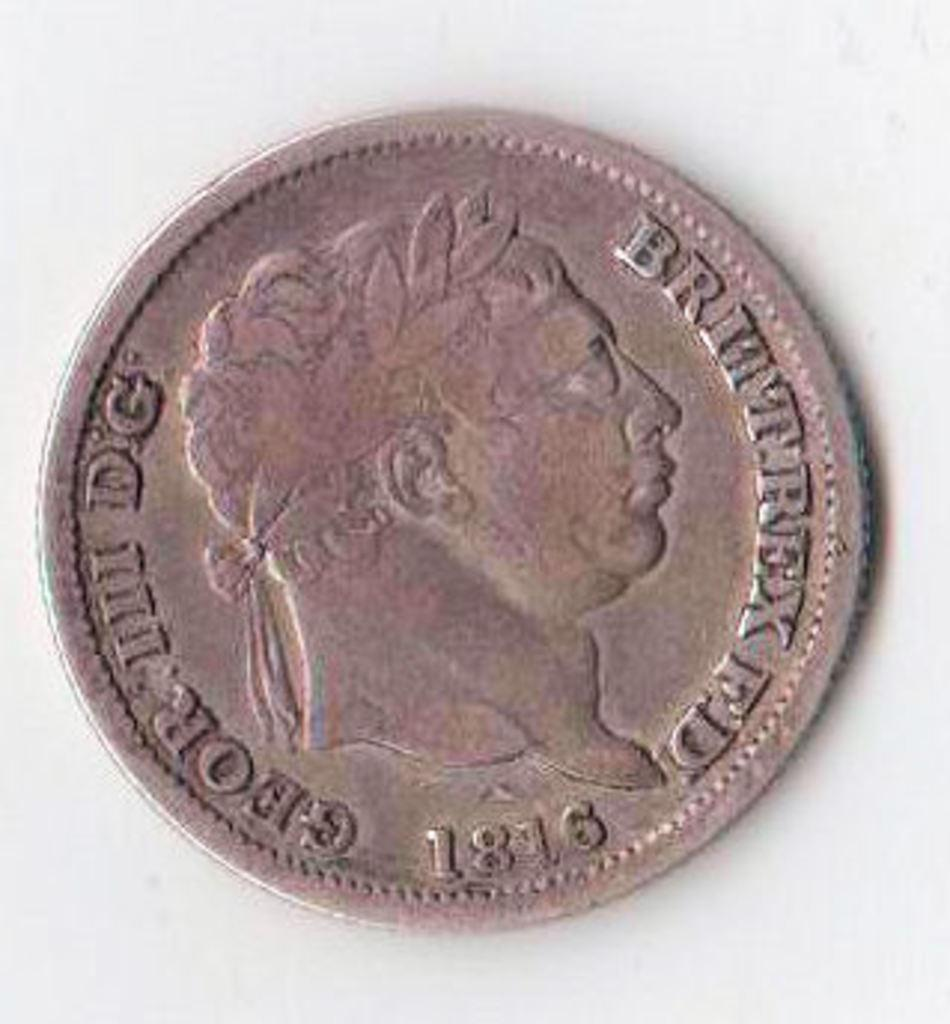<image>
Relay a brief, clear account of the picture shown. A coin from 1816 has Geor III D.G. on it. 